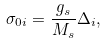<formula> <loc_0><loc_0><loc_500><loc_500>\sigma _ { 0 i } = \frac { g _ { s } } { M _ { s } } \Delta _ { i } ,</formula> 